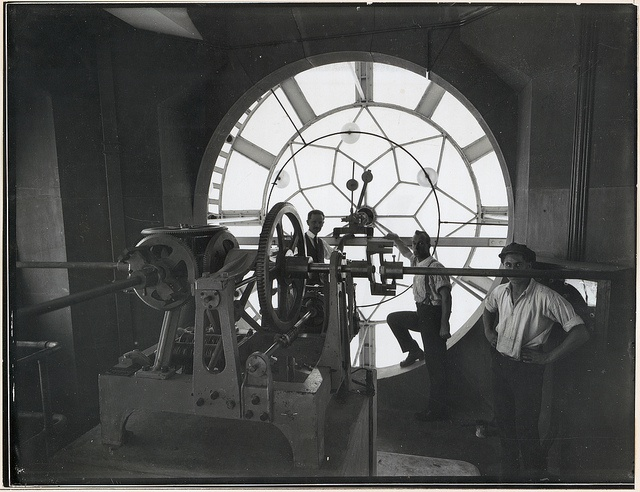Describe the objects in this image and their specific colors. I can see clock in lightgray, white, darkgray, gray, and black tones, people in lightgray, black, gray, and darkgray tones, people in lightgray, black, gray, white, and darkgray tones, people in lightgray, black, gray, and darkgray tones, and tie in lightgray, black, gray, and darkgray tones in this image. 